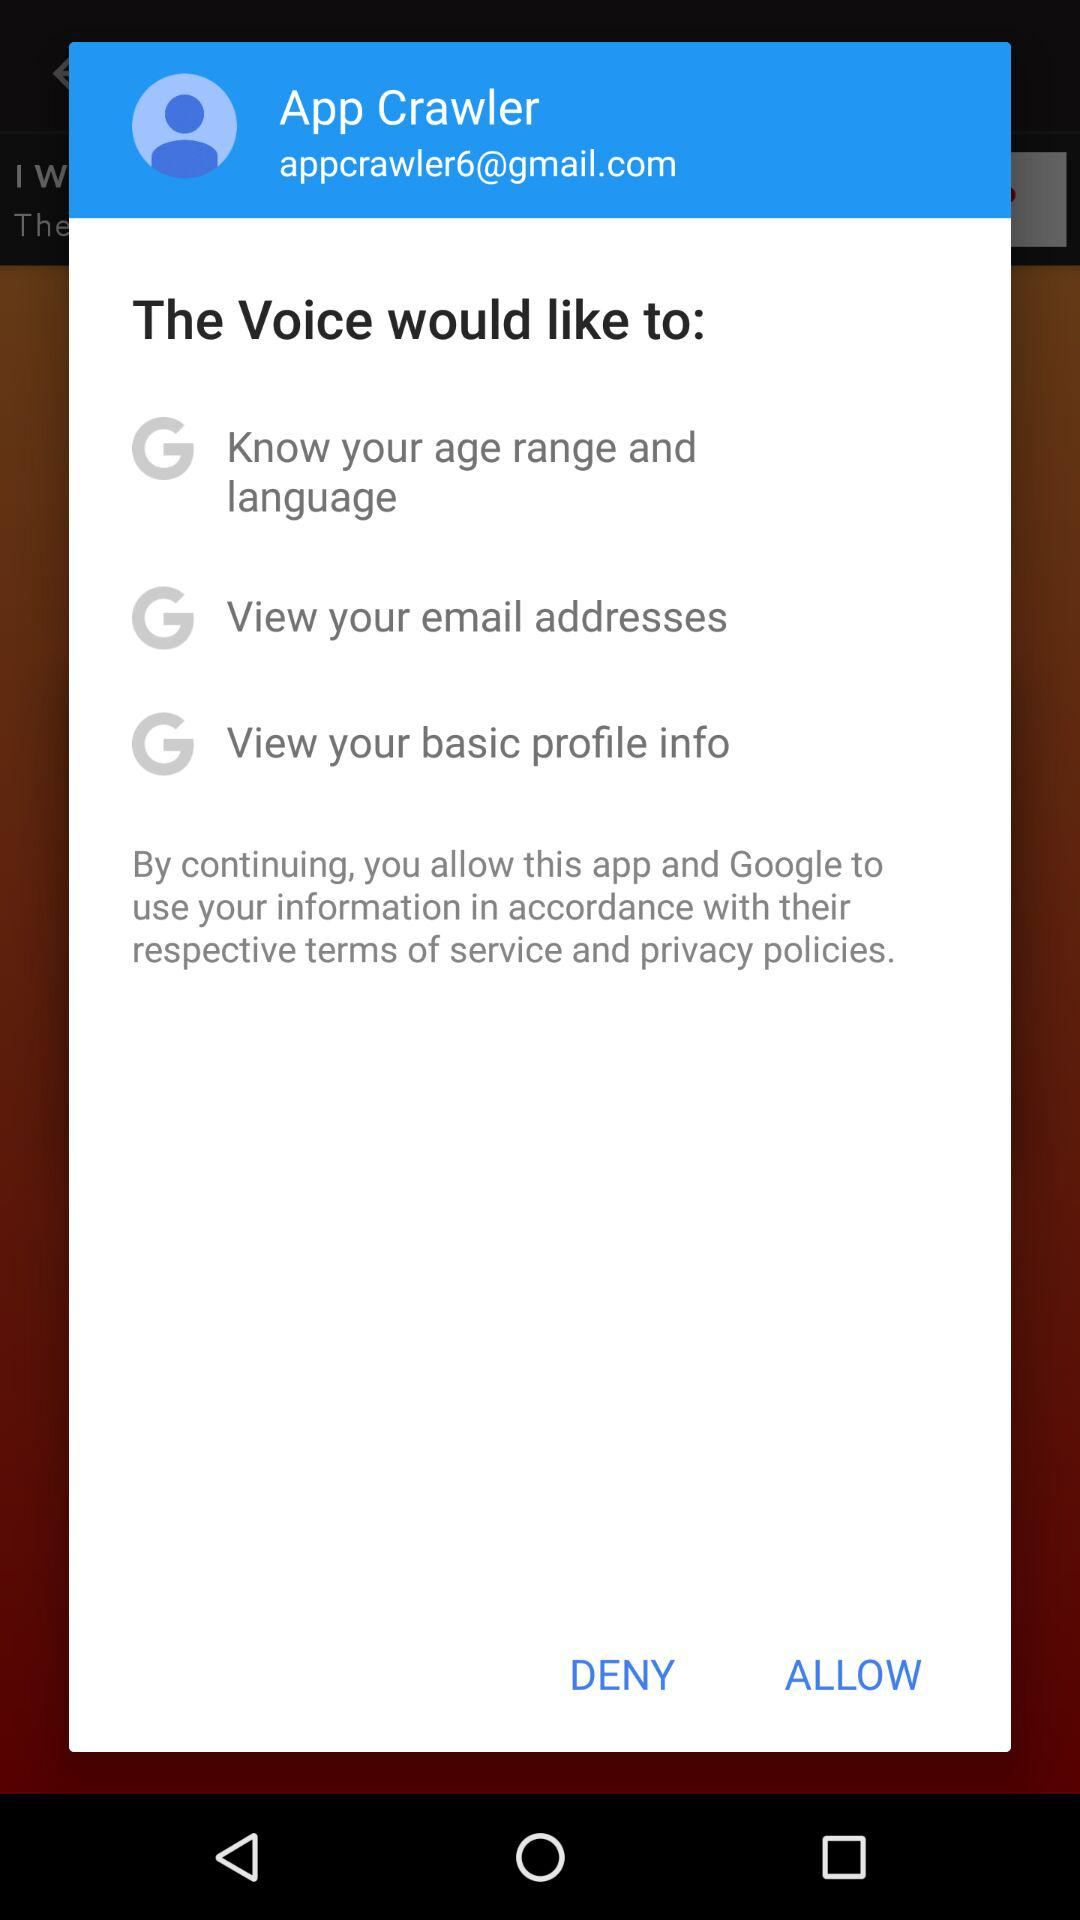How many items does the user need to approve to allow access to their information?
Answer the question using a single word or phrase. 3 